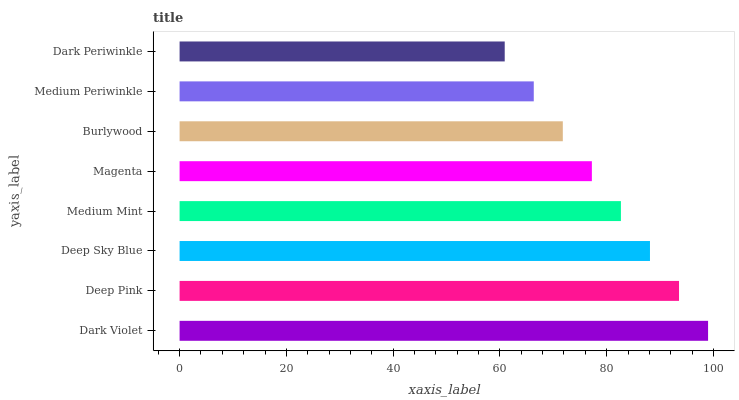Is Dark Periwinkle the minimum?
Answer yes or no. Yes. Is Dark Violet the maximum?
Answer yes or no. Yes. Is Deep Pink the minimum?
Answer yes or no. No. Is Deep Pink the maximum?
Answer yes or no. No. Is Dark Violet greater than Deep Pink?
Answer yes or no. Yes. Is Deep Pink less than Dark Violet?
Answer yes or no. Yes. Is Deep Pink greater than Dark Violet?
Answer yes or no. No. Is Dark Violet less than Deep Pink?
Answer yes or no. No. Is Medium Mint the high median?
Answer yes or no. Yes. Is Magenta the low median?
Answer yes or no. Yes. Is Dark Violet the high median?
Answer yes or no. No. Is Medium Mint the low median?
Answer yes or no. No. 